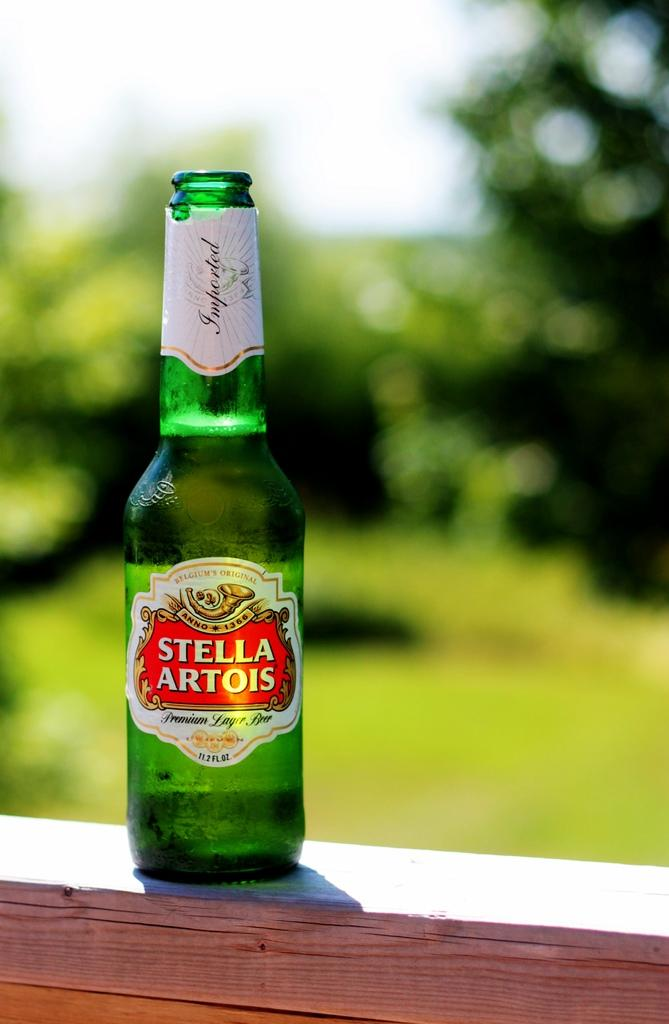<image>
Provide a brief description of the given image. the word stella is on the front of a bottle 